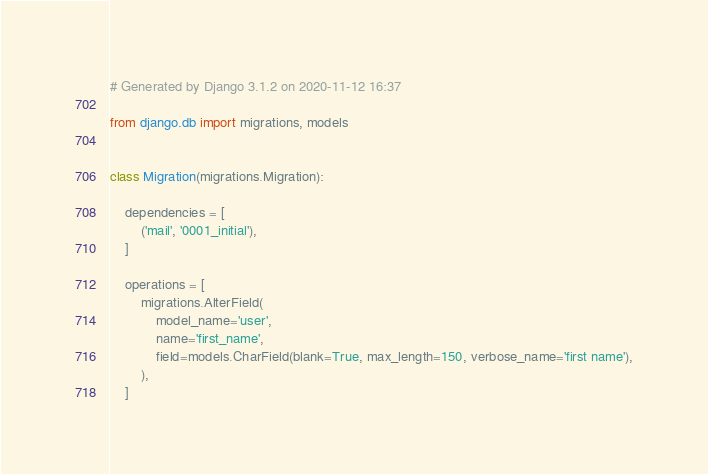Convert code to text. <code><loc_0><loc_0><loc_500><loc_500><_Python_># Generated by Django 3.1.2 on 2020-11-12 16:37

from django.db import migrations, models


class Migration(migrations.Migration):

    dependencies = [
        ('mail', '0001_initial'),
    ]

    operations = [
        migrations.AlterField(
            model_name='user',
            name='first_name',
            field=models.CharField(blank=True, max_length=150, verbose_name='first name'),
        ),
    ]
</code> 